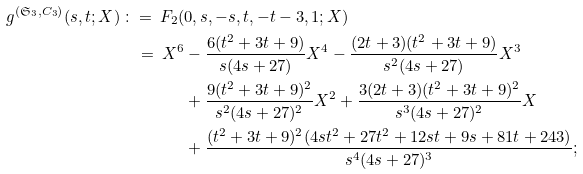<formula> <loc_0><loc_0><loc_500><loc_500>g ^ { ( \mathfrak { S } _ { 3 } , C _ { 3 } ) } ( s , t ; X ) \, \colon = \, F _ { 2 } ( & 0 , s , - s , t , - t - 3 , 1 ; X ) \\ \, = \, X ^ { 6 } & - \frac { 6 ( t ^ { 2 } + 3 t + 9 ) } { s ( 4 s + 2 7 ) } X ^ { 4 } - \frac { ( 2 t + 3 ) ( t ^ { 2 } + 3 t + 9 ) } { s ^ { 2 } ( 4 s + 2 7 ) } X ^ { 3 } \\ & + \frac { 9 ( t ^ { 2 } + 3 t + 9 ) ^ { 2 } } { s ^ { 2 } ( 4 s + 2 7 ) ^ { 2 } } X ^ { 2 } + \frac { 3 ( 2 t + 3 ) ( t ^ { 2 } + 3 t + 9 ) ^ { 2 } } { s ^ { 3 } ( 4 s + 2 7 ) ^ { 2 } } X \\ & + \frac { ( t ^ { 2 } + 3 t + 9 ) ^ { 2 } ( 4 s t ^ { 2 } + 2 7 t ^ { 2 } + 1 2 s t + 9 s + 8 1 t + 2 4 3 ) } { s ^ { 4 } ( 4 s + 2 7 ) ^ { 3 } } ;</formula> 